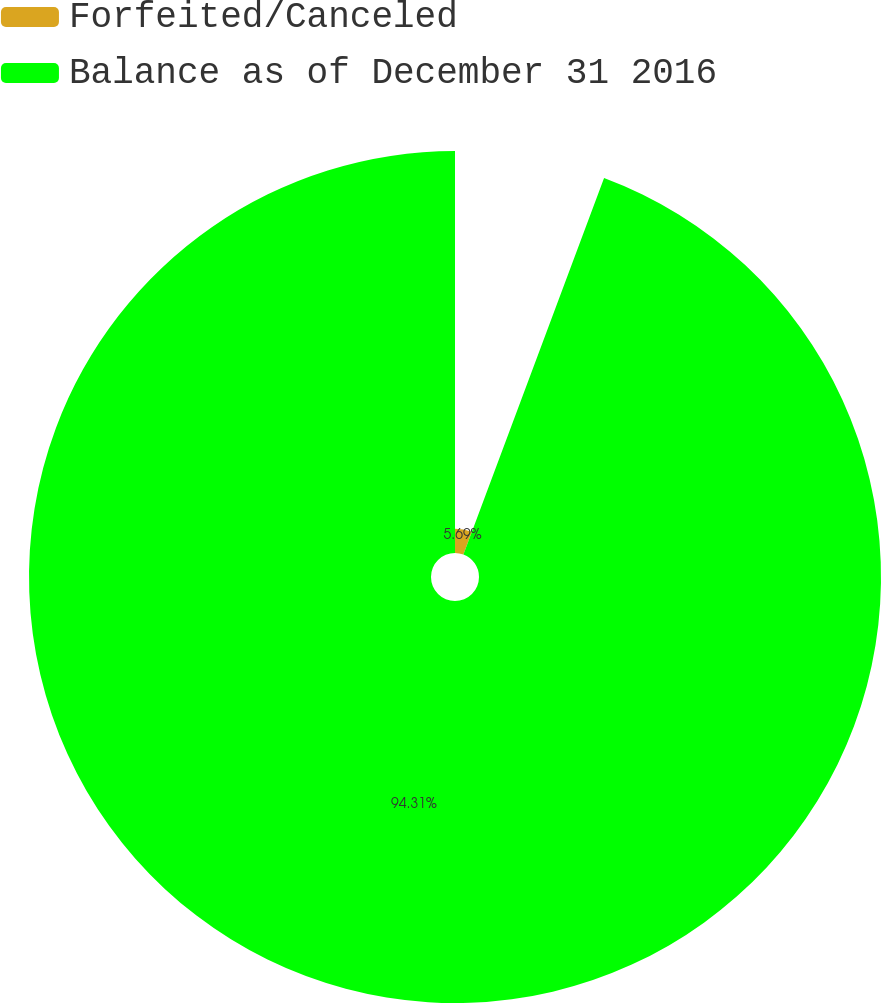<chart> <loc_0><loc_0><loc_500><loc_500><pie_chart><fcel>Forfeited/Canceled<fcel>Balance as of December 31 2016<nl><fcel>5.69%<fcel>94.31%<nl></chart> 